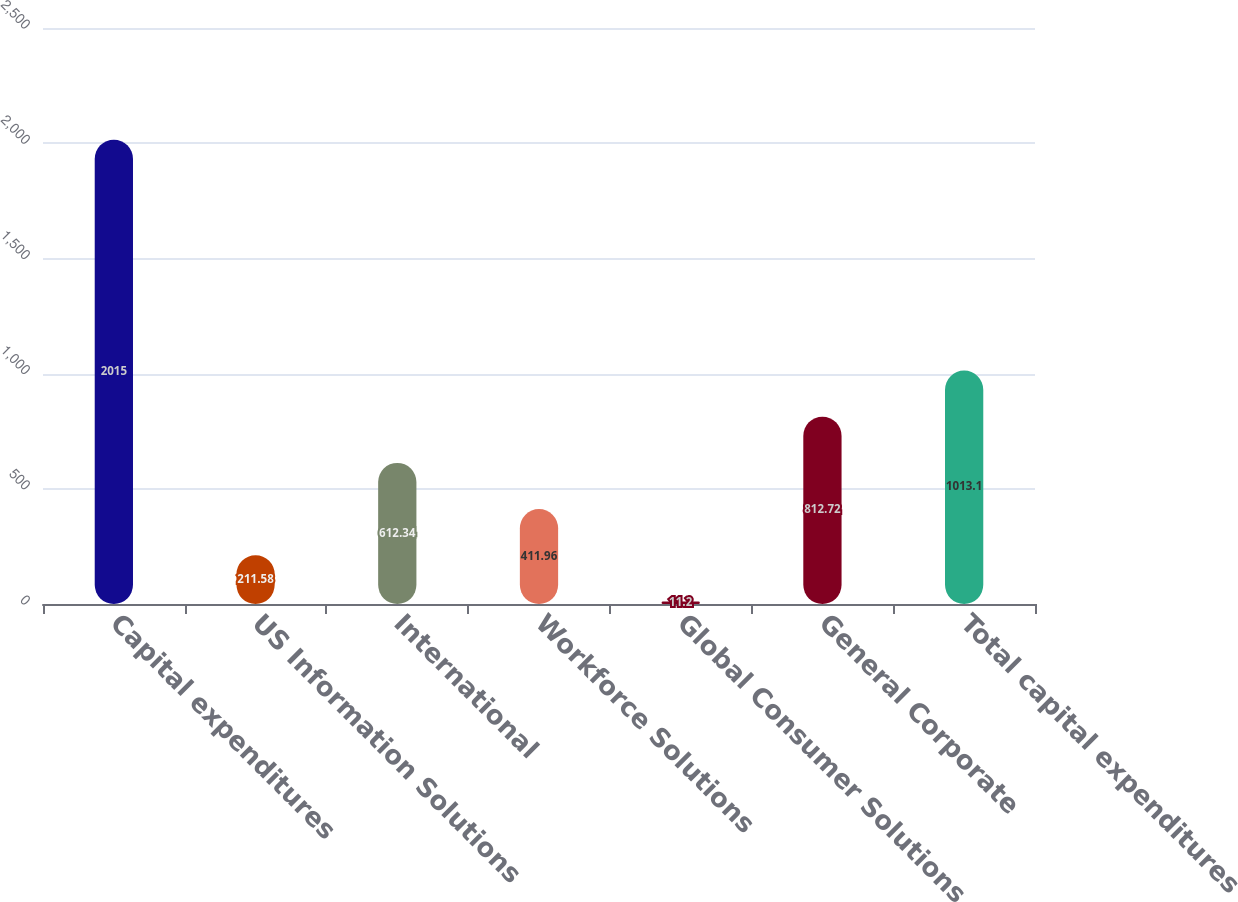Convert chart to OTSL. <chart><loc_0><loc_0><loc_500><loc_500><bar_chart><fcel>Capital expenditures<fcel>US Information Solutions<fcel>International<fcel>Workforce Solutions<fcel>Global Consumer Solutions<fcel>General Corporate<fcel>Total capital expenditures<nl><fcel>2015<fcel>211.58<fcel>612.34<fcel>411.96<fcel>11.2<fcel>812.72<fcel>1013.1<nl></chart> 